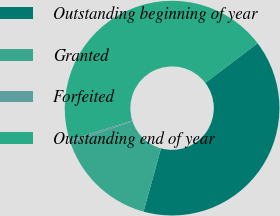Convert chart to OTSL. <chart><loc_0><loc_0><loc_500><loc_500><pie_chart><fcel>Outstanding beginning of year<fcel>Granted<fcel>Forfeited<fcel>Outstanding end of year<nl><fcel>39.62%<fcel>15.57%<fcel>0.35%<fcel>44.46%<nl></chart> 